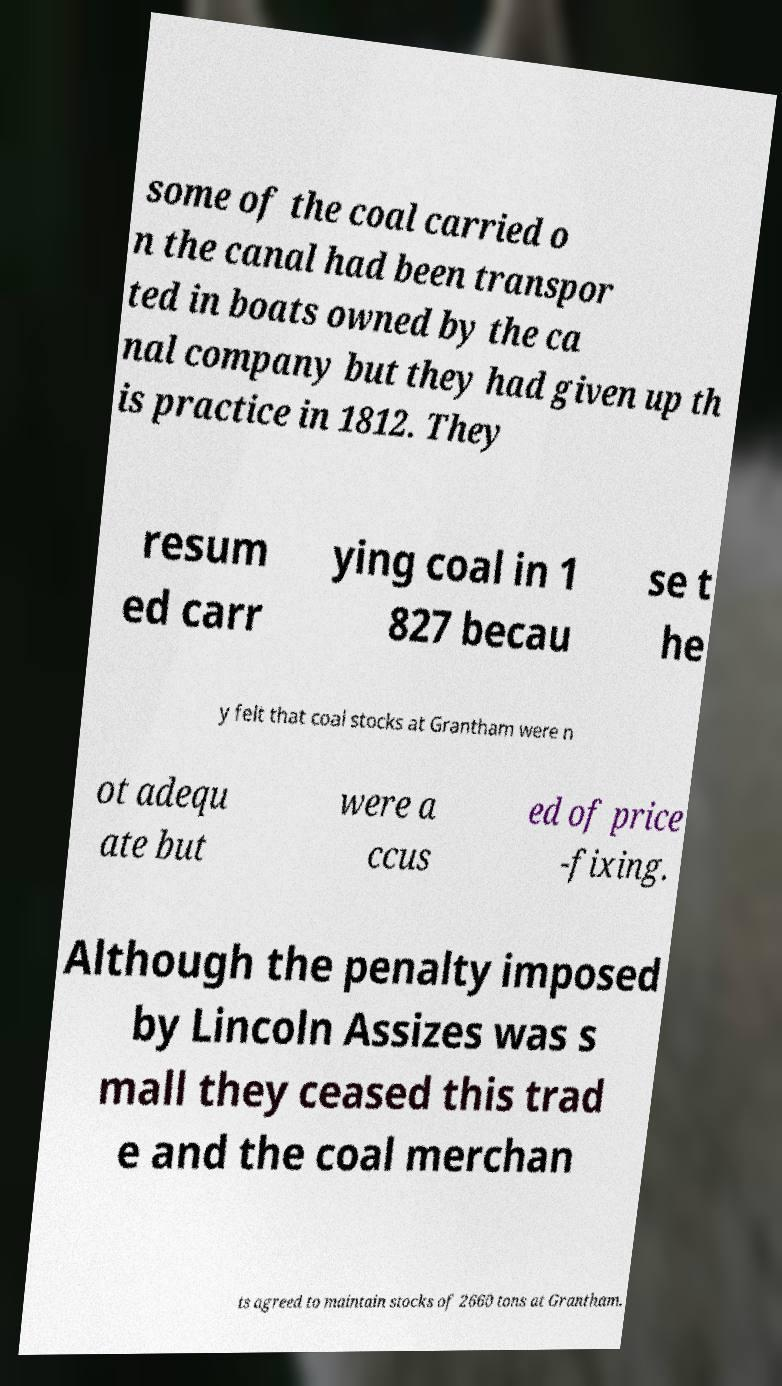Can you accurately transcribe the text from the provided image for me? some of the coal carried o n the canal had been transpor ted in boats owned by the ca nal company but they had given up th is practice in 1812. They resum ed carr ying coal in 1 827 becau se t he y felt that coal stocks at Grantham were n ot adequ ate but were a ccus ed of price -fixing. Although the penalty imposed by Lincoln Assizes was s mall they ceased this trad e and the coal merchan ts agreed to maintain stocks of 2660 tons at Grantham. 